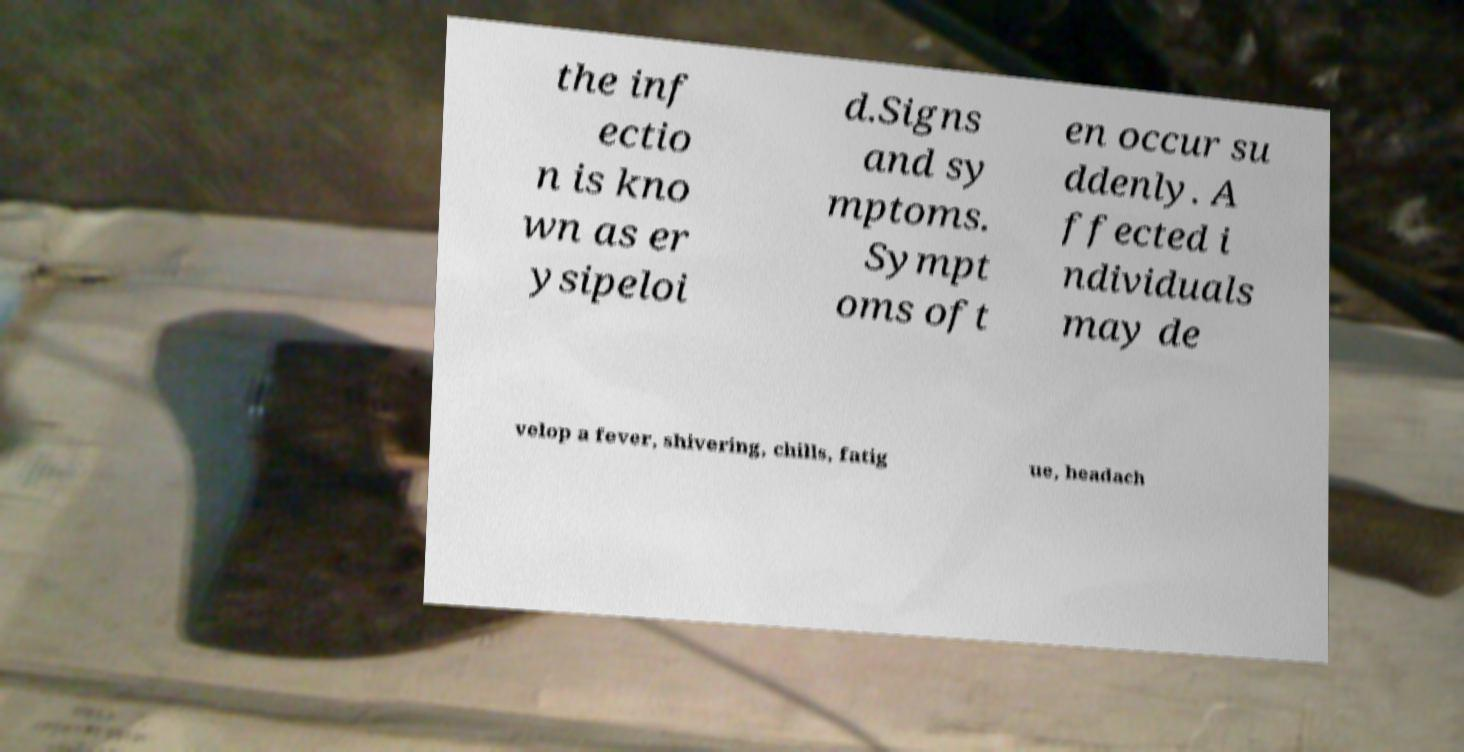There's text embedded in this image that I need extracted. Can you transcribe it verbatim? the inf ectio n is kno wn as er ysipeloi d.Signs and sy mptoms. Sympt oms oft en occur su ddenly. A ffected i ndividuals may de velop a fever, shivering, chills, fatig ue, headach 